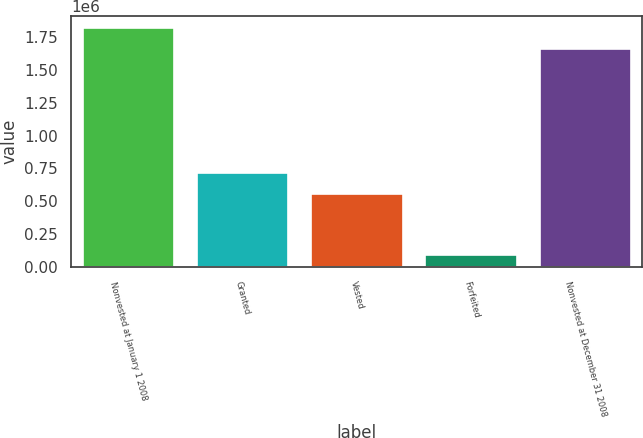<chart> <loc_0><loc_0><loc_500><loc_500><bar_chart><fcel>Nonvested at January 1 2008<fcel>Granted<fcel>Vested<fcel>Forfeited<fcel>Nonvested at December 31 2008<nl><fcel>1.8177e+06<fcel>719147<fcel>558281<fcel>95974<fcel>1.65683e+06<nl></chart> 